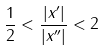<formula> <loc_0><loc_0><loc_500><loc_500>\frac { 1 } { 2 } < \frac { | x ^ { \prime } | } { | x ^ { \prime \prime } | } < 2</formula> 